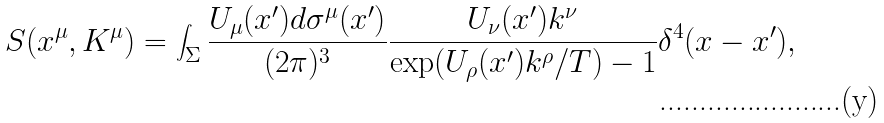<formula> <loc_0><loc_0><loc_500><loc_500>S ( x ^ { \mu } , K ^ { \mu } ) = \int _ { \Sigma } \frac { U _ { \mu } ( x ^ { \prime } ) d \sigma ^ { \mu } ( x ^ { \prime } ) } { ( 2 \pi ) ^ { 3 } } \frac { U _ { \nu } ( x ^ { \prime } ) k ^ { \nu } } { \exp ( U _ { \rho } ( x ^ { \prime } ) k ^ { \rho } / T ) - 1 } \delta ^ { 4 } ( x - x ^ { \prime } ) ,</formula> 